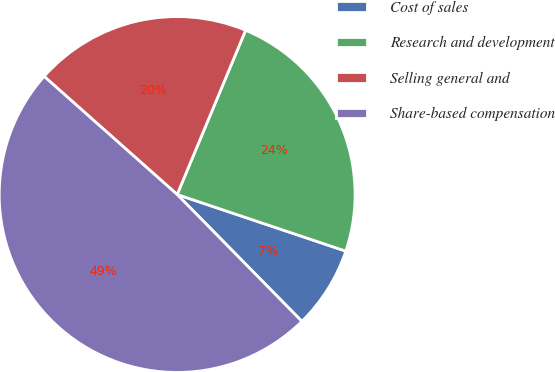Convert chart. <chart><loc_0><loc_0><loc_500><loc_500><pie_chart><fcel>Cost of sales<fcel>Research and development<fcel>Selling general and<fcel>Share-based compensation<nl><fcel>7.48%<fcel>23.87%<fcel>19.73%<fcel>48.92%<nl></chart> 